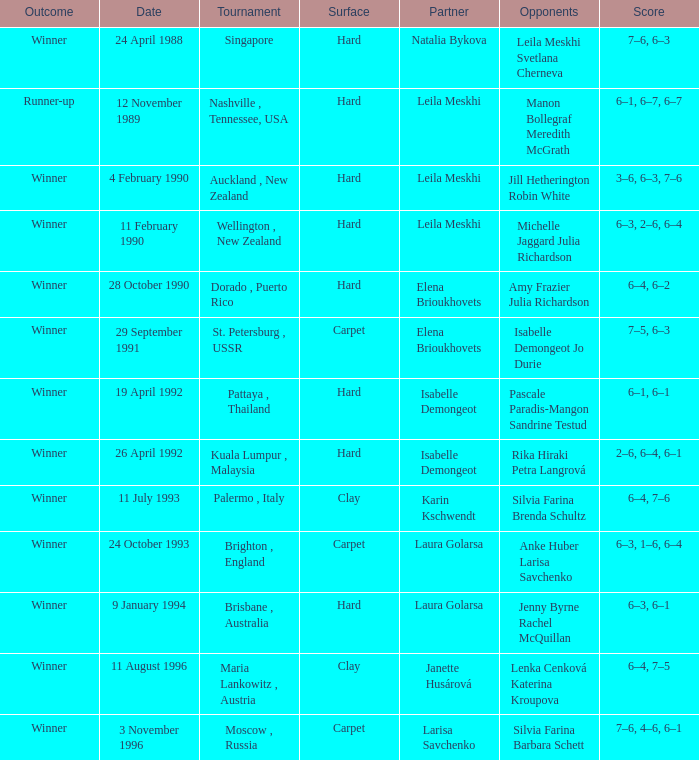In what Tournament was the Score of 3–6, 6–3, 7–6 in a match played on a hard Surface? Auckland , New Zealand. 